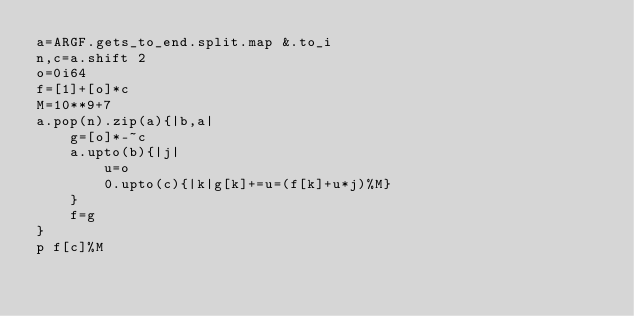<code> <loc_0><loc_0><loc_500><loc_500><_Crystal_>a=ARGF.gets_to_end.split.map &.to_i
n,c=a.shift 2
o=0i64
f=[1]+[o]*c
M=10**9+7
a.pop(n).zip(a){|b,a|
	g=[o]*-~c
	a.upto(b){|j|
		u=o
    	0.upto(c){|k|g[k]+=u=(f[k]+u*j)%M}
	}
	f=g
}
p f[c]%M</code> 